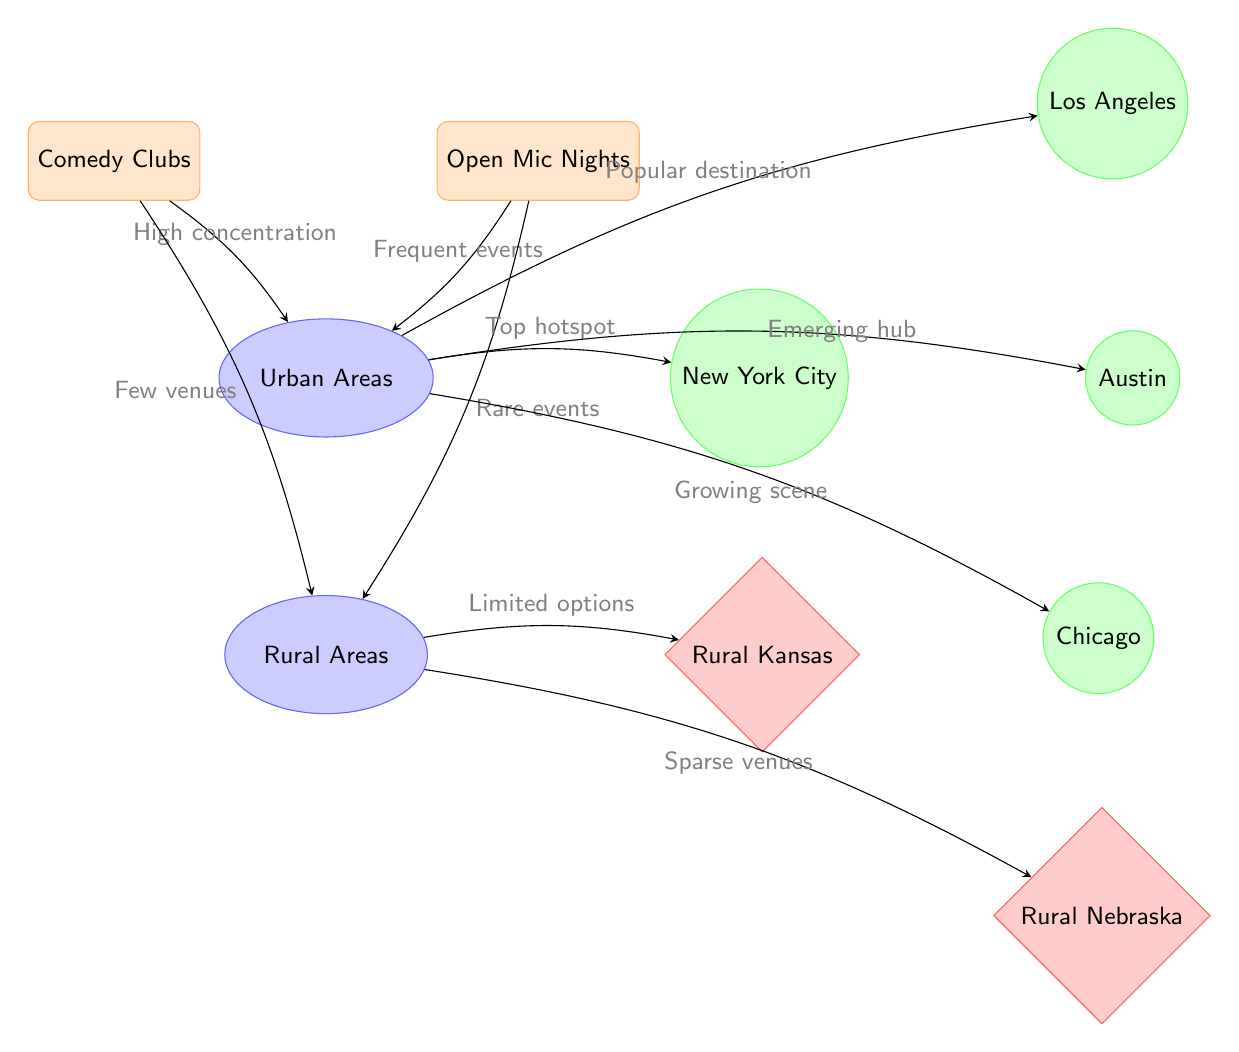What are the two types of venues represented in the diagram? The diagram specifically identifies two types of venues: "Comedy Clubs" and "Open Mic Nights". These are both labeled as venues in the diagram, illustrated in rectangular nodes.
Answer: Comedy Clubs, Open Mic Nights Which area has a high concentration of comedy clubs? According to the diagram, the "Urban Areas" section indicates a high concentration of "Comedy Clubs", as shown by the arrow connecting the two.
Answer: Urban Areas How many cities are listed in the urban areas? The urban area has four listed cities: New York City, Los Angeles, Chicago, and Austin. Counting these names results in a total of four cities.
Answer: 4 What type of events are indicated in rural areas? In rural areas, the diagram states "Rare events" related to "Open Mic Nights", reflecting the limited opportunities for these events as compared to urban areas.
Answer: Rare events Which city is labeled as the "Top hotspot"? The city identified as the "Top hotspot" in urban areas is "New York City", as shown by the edge connecting urban areas with New York City and the description provided.
Answer: New York City What does the diagram suggest about the availability of comedy venues in rural areas? The diagram indicates there are "Few venues" for "Comedy Clubs" and "Sparse venues" for "Open Mic Nights" in rural areas, highlighting the limited availability in these regions.
Answer: Few venues, Sparse venues Which urban area is described as an "Emerging hub"? The diagram describes "Austin" as an "Emerging hub" for comedy within urban areas, denoted by the label connected to the urban section.
Answer: Austin What is the relationship between "Open Mic Nights" and urban areas? The relationship shows that "Open Mic Nights" occur with "Frequent events" in "Urban Areas", indicating a thriving comedy scene in these locations.
Answer: Frequent events How does the diagram characterize rural Nebraska? The diagram characterizes "Rural Nebraska" with "Sparse venues", indicating that there are very few options for comedy in that area, as illustrated by the connection from rural areas to that city.
Answer: Sparse venues 